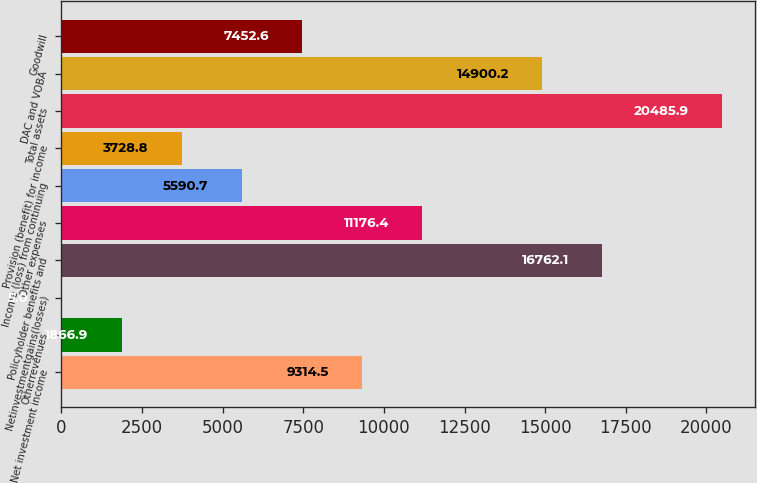Convert chart. <chart><loc_0><loc_0><loc_500><loc_500><bar_chart><fcel>Net investment income<fcel>Otherrevenues<fcel>Netinvestmentgains(losses)<fcel>Policyholder benefits and<fcel>Other expenses<fcel>Income (loss) from continuing<fcel>Provision (benefit) for income<fcel>Total assets<fcel>DAC and VOBA<fcel>Goodwill<nl><fcel>9314.5<fcel>1866.9<fcel>5<fcel>16762.1<fcel>11176.4<fcel>5590.7<fcel>3728.8<fcel>20485.9<fcel>14900.2<fcel>7452.6<nl></chart> 